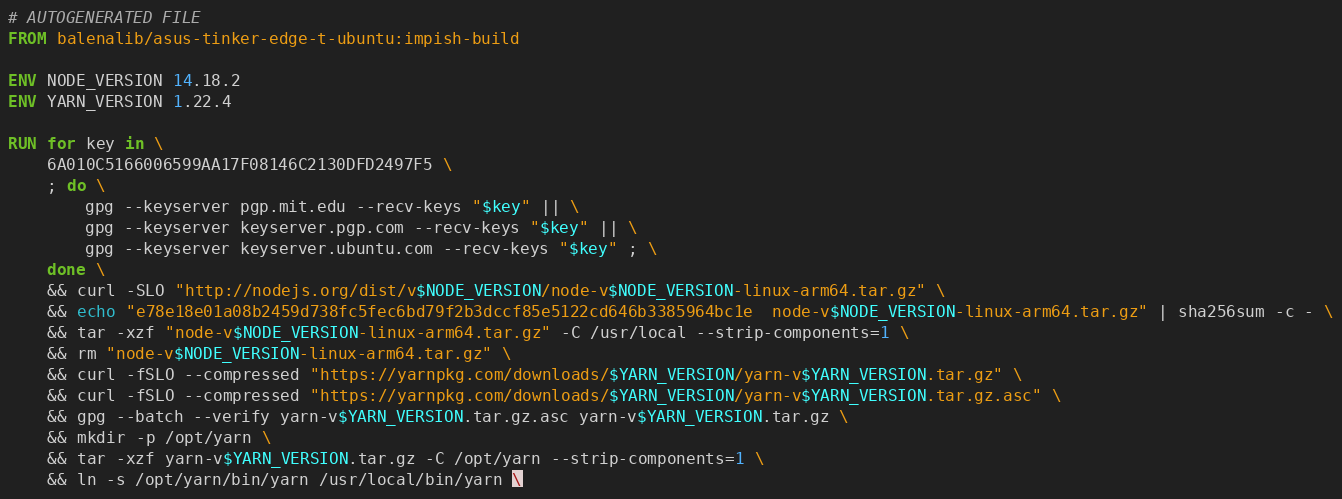Convert code to text. <code><loc_0><loc_0><loc_500><loc_500><_Dockerfile_># AUTOGENERATED FILE
FROM balenalib/asus-tinker-edge-t-ubuntu:impish-build

ENV NODE_VERSION 14.18.2
ENV YARN_VERSION 1.22.4

RUN for key in \
	6A010C5166006599AA17F08146C2130DFD2497F5 \
	; do \
		gpg --keyserver pgp.mit.edu --recv-keys "$key" || \
		gpg --keyserver keyserver.pgp.com --recv-keys "$key" || \
		gpg --keyserver keyserver.ubuntu.com --recv-keys "$key" ; \
	done \
	&& curl -SLO "http://nodejs.org/dist/v$NODE_VERSION/node-v$NODE_VERSION-linux-arm64.tar.gz" \
	&& echo "e78e18e01a08b2459d738fc5fec6bd79f2b3dccf85e5122cd646b3385964bc1e  node-v$NODE_VERSION-linux-arm64.tar.gz" | sha256sum -c - \
	&& tar -xzf "node-v$NODE_VERSION-linux-arm64.tar.gz" -C /usr/local --strip-components=1 \
	&& rm "node-v$NODE_VERSION-linux-arm64.tar.gz" \
	&& curl -fSLO --compressed "https://yarnpkg.com/downloads/$YARN_VERSION/yarn-v$YARN_VERSION.tar.gz" \
	&& curl -fSLO --compressed "https://yarnpkg.com/downloads/$YARN_VERSION/yarn-v$YARN_VERSION.tar.gz.asc" \
	&& gpg --batch --verify yarn-v$YARN_VERSION.tar.gz.asc yarn-v$YARN_VERSION.tar.gz \
	&& mkdir -p /opt/yarn \
	&& tar -xzf yarn-v$YARN_VERSION.tar.gz -C /opt/yarn --strip-components=1 \
	&& ln -s /opt/yarn/bin/yarn /usr/local/bin/yarn \</code> 